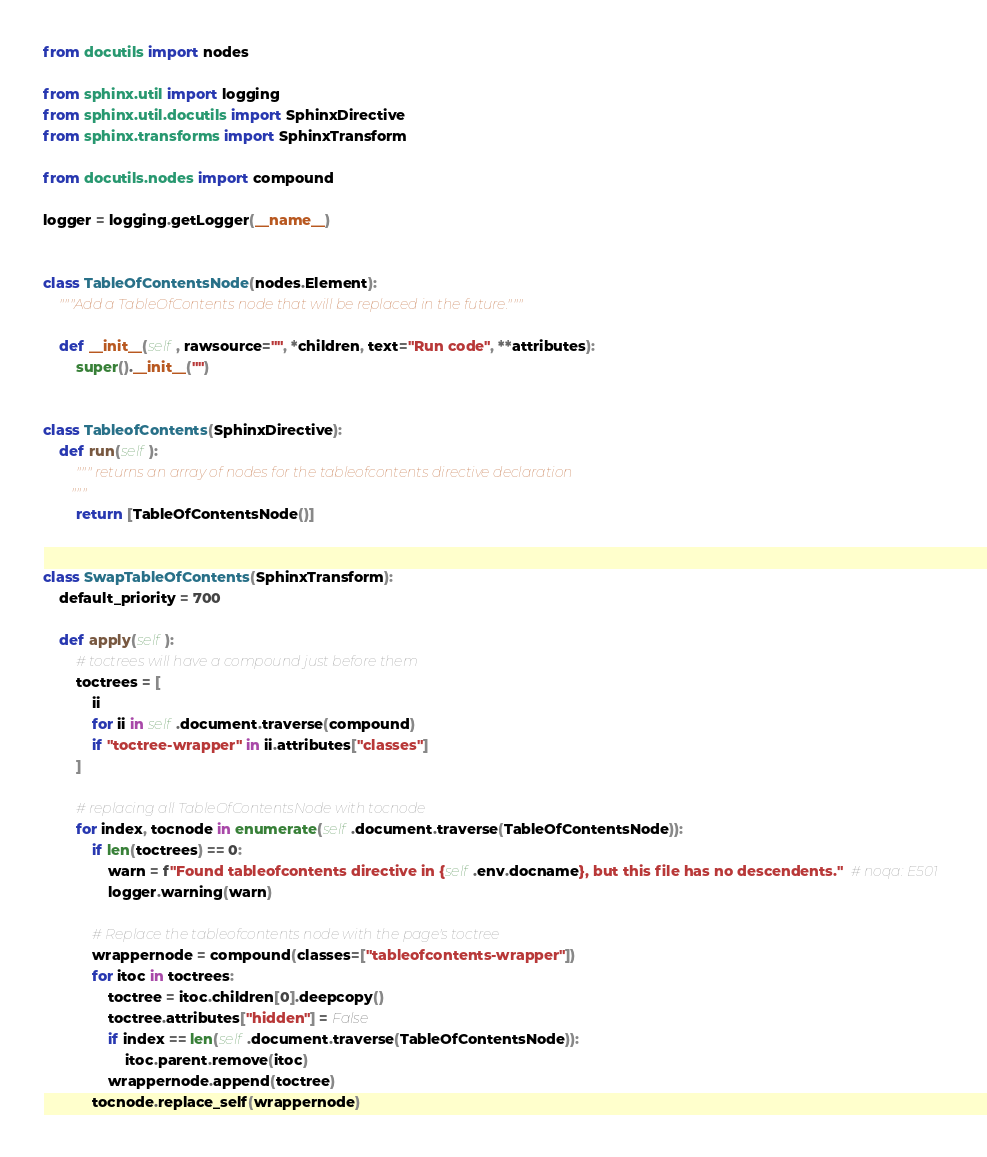<code> <loc_0><loc_0><loc_500><loc_500><_Python_>from docutils import nodes

from sphinx.util import logging
from sphinx.util.docutils import SphinxDirective
from sphinx.transforms import SphinxTransform

from docutils.nodes import compound

logger = logging.getLogger(__name__)


class TableOfContentsNode(nodes.Element):
    """Add a TableOfContents node that will be replaced in the future."""

    def __init__(self, rawsource="", *children, text="Run code", **attributes):
        super().__init__("")


class TableofContents(SphinxDirective):
    def run(self):
        """ returns an array of nodes for the tableofcontents directive declaration
        """
        return [TableOfContentsNode()]


class SwapTableOfContents(SphinxTransform):
    default_priority = 700

    def apply(self):
        # toctrees will have a compound just before them
        toctrees = [
            ii
            for ii in self.document.traverse(compound)
            if "toctree-wrapper" in ii.attributes["classes"]
        ]

        # replacing all TableOfContentsNode with tocnode
        for index, tocnode in enumerate(self.document.traverse(TableOfContentsNode)):
            if len(toctrees) == 0:
                warn = f"Found tableofcontents directive in {self.env.docname}, but this file has no descendents."  # noqa: E501
                logger.warning(warn)

            # Replace the tableofcontents node with the page's toctree
            wrappernode = compound(classes=["tableofcontents-wrapper"])
            for itoc in toctrees:
                toctree = itoc.children[0].deepcopy()
                toctree.attributes["hidden"] = False
                if index == len(self.document.traverse(TableOfContentsNode)):
                    itoc.parent.remove(itoc)
                wrappernode.append(toctree)
            tocnode.replace_self(wrappernode)
</code> 